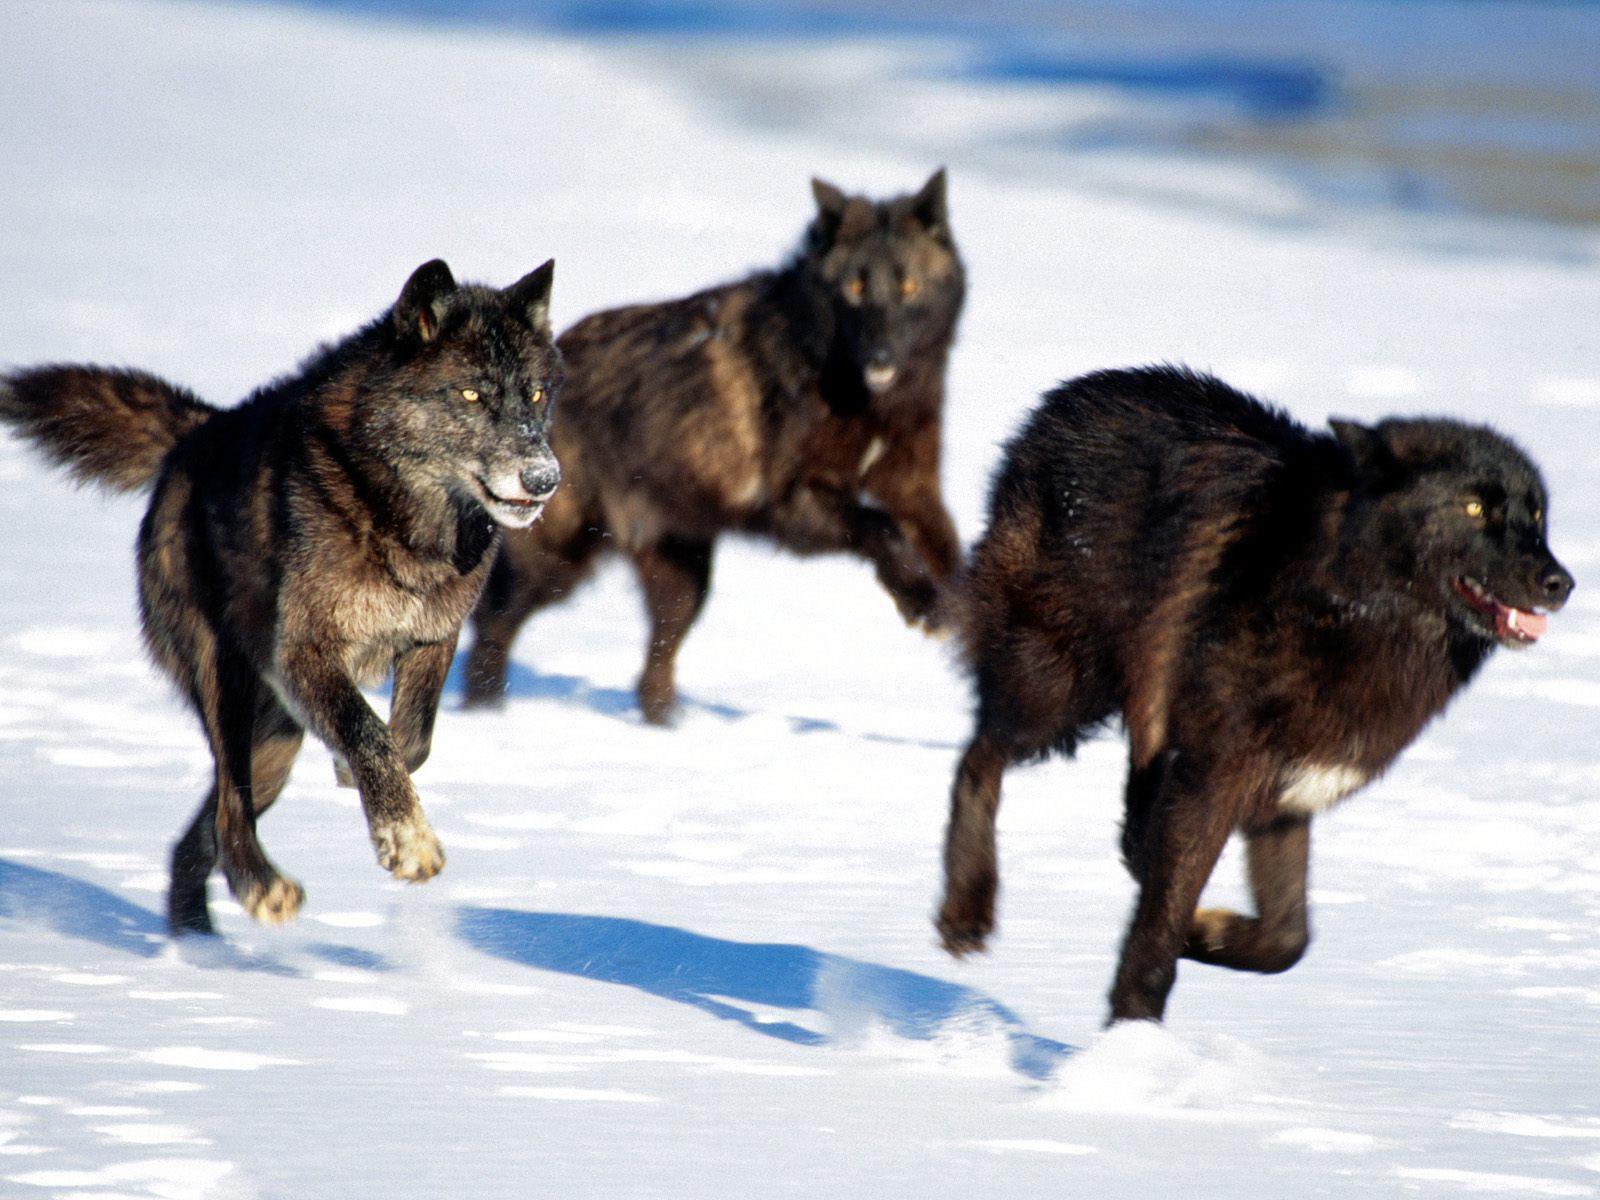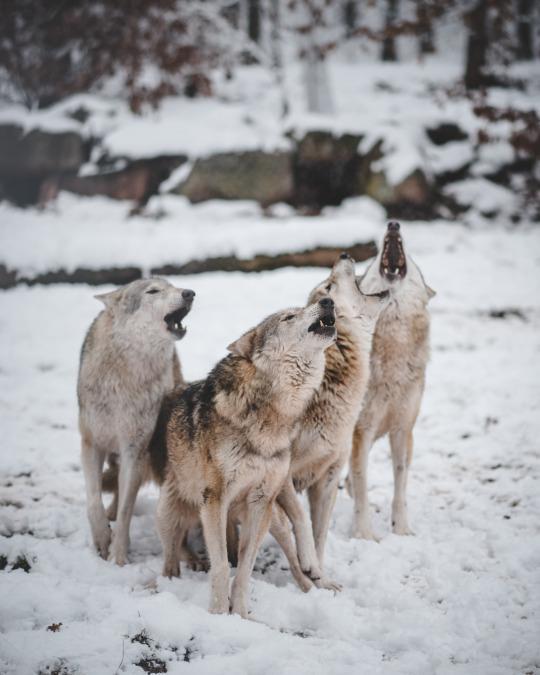The first image is the image on the left, the second image is the image on the right. Given the left and right images, does the statement "A non-canine mammal can be seen in one or more of the images." hold true? Answer yes or no. No. The first image is the image on the left, the second image is the image on the right. Evaluate the accuracy of this statement regarding the images: "There are no more than two wolves.". Is it true? Answer yes or no. No. 